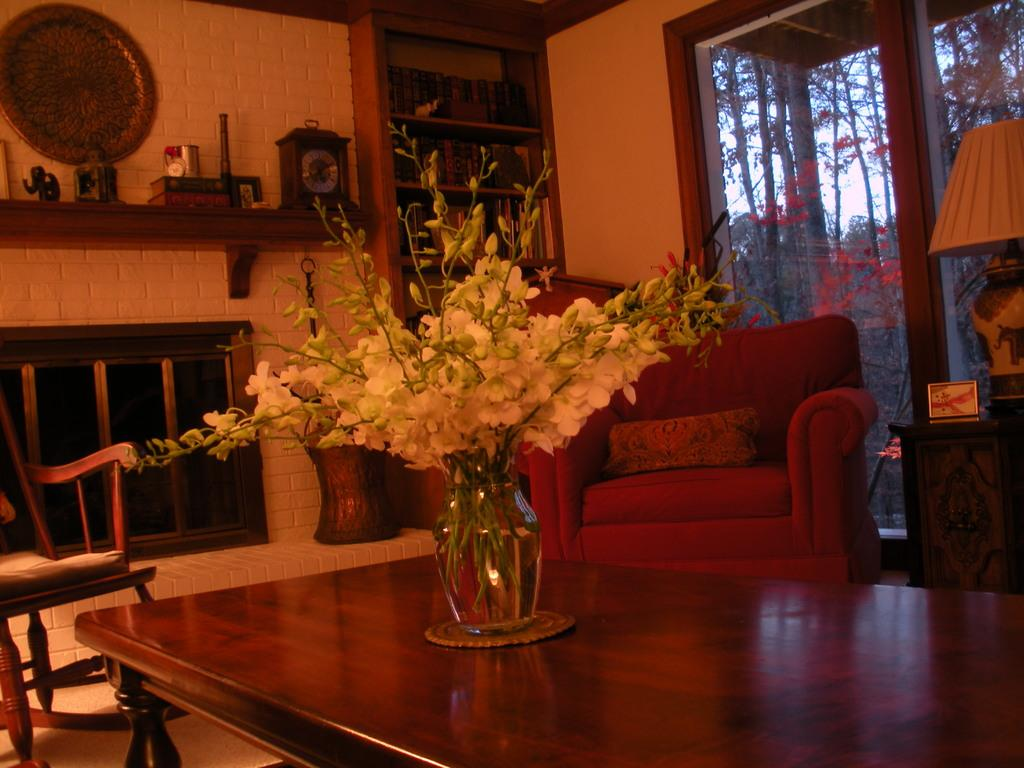What is on the table in the image? There is a flower vase on a table in the image. What can be seen in the background of the image? In the background of the image, there is a fireplace, a chair, a cupboard, books, a clock, a toy elephant, trees, windows, and a lamp. What type of furniture is present in the background of the image? There is a chair, a cupboard, and a couch in the background of the image. What might be used for telling time in the image? There is a clock in the background of the image. What type of decision can be seen being made in the image? There is no decision-making process depicted in the image. What type of kite can be seen flying in the background of the image? There is no kite present in the image. 